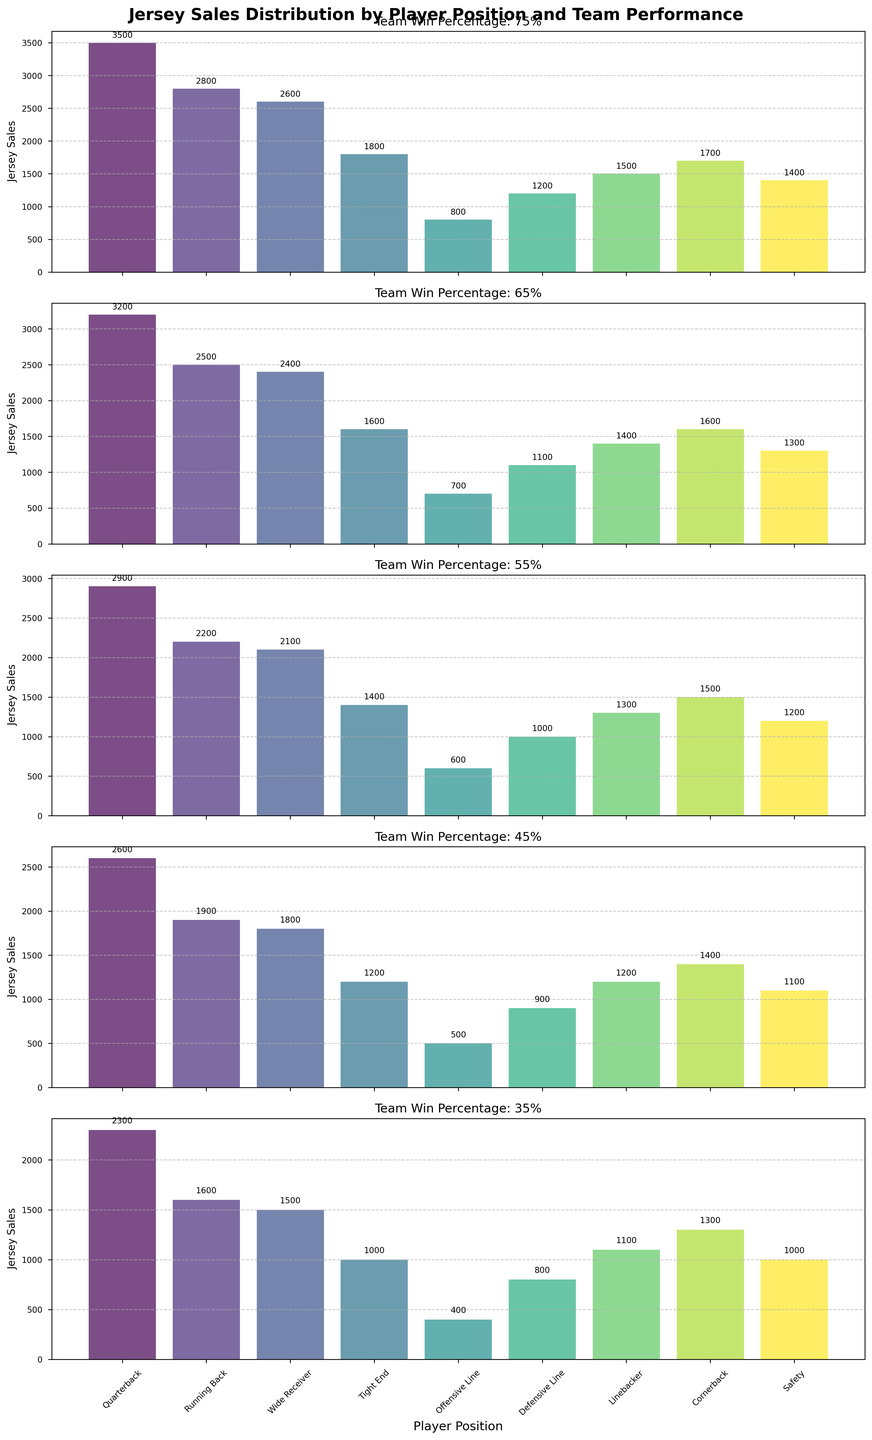What's the total number of Jersey sales for the Team Win Percentage of 0.75? Add up all the Jersey sales for each position under the 0.75 Team Win Percentage: 3500 (Quarterback) + 2800 (Running Back) + 2600 (Wide Receiver) + 1800 (Tight End) + 800 (Offensive Line) + 1200 (Defensive Line) + 1500 (Linebacker) + 1700 (Cornerback) + 1400 (Safety) = 18300
Answer: 18300 Which player position has the highest Jersey sales for the Team Win Percentage of 0.65? Look at the bars for the Team Win Percentage of 0.65 and identify the highest bar, which corresponds to the Quarterback at 3200.
Answer: Quarterback How do the Jersey sales for the Running Back position compare between the Team Win Percentages of 0.75 and 0.45? The Jersey sales for the Running Back are 2800 at a 0.75 Team Win Percentage and 1900 at a 0.45 Team Win Percentage. Comparing these, 2800 is greater than 1900.
Answer: 2800 > 1900 What's the average Jersey sales for Quarterbacks across all Team Win Percentages? Find the Jersey sales for Quarterbacks across all percentages: 3500, 3200, 2900, 2600, 2300. Calculate the average: (3500 + 3200 + 2900 + 2600 + 2300) / 5 = 2900
Answer: 2900 In which Team Win Percentage do Offensive Line players have the lowest Jersey sales? Look at the bars for the Offensive Line across all Team Win Percentages and identify the lowest bar. The lowest sales are 400 under the 0.35 Team Win Percentage.
Answer: 0.35 Which player position shows the least variation in Jersey sales across different Team Win Percentages? By visually inspecting the height of bars for each player position across all win percentages, the Offensive Line position shows the least variation with consistent low sales.
Answer: Offensive Line For the Team Win Percentage of 0.45, which player position has the second-highest Jersey sales? Look at the bars for the 0.45 Team Win Percentage and identify the second-highest bar, which corresponds to the Cornerback with 1400.
Answer: Cornerback How many more Jersey sales do Quarterbacks have compared to Tight Ends for the Team Win Percentage of 0.55? The Jersey sales for Quarterbacks are 2900 and for Tight Ends are 1400. The difference is 2900 - 1400 = 1500
Answer: 1500 